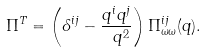Convert formula to latex. <formula><loc_0><loc_0><loc_500><loc_500>\Pi ^ { T } = \left ( \delta ^ { i j } - \frac { q ^ { i } q ^ { j } } { \ q ^ { 2 } } \right ) \Pi _ { \omega \omega } ^ { i j } ( q ) .</formula> 